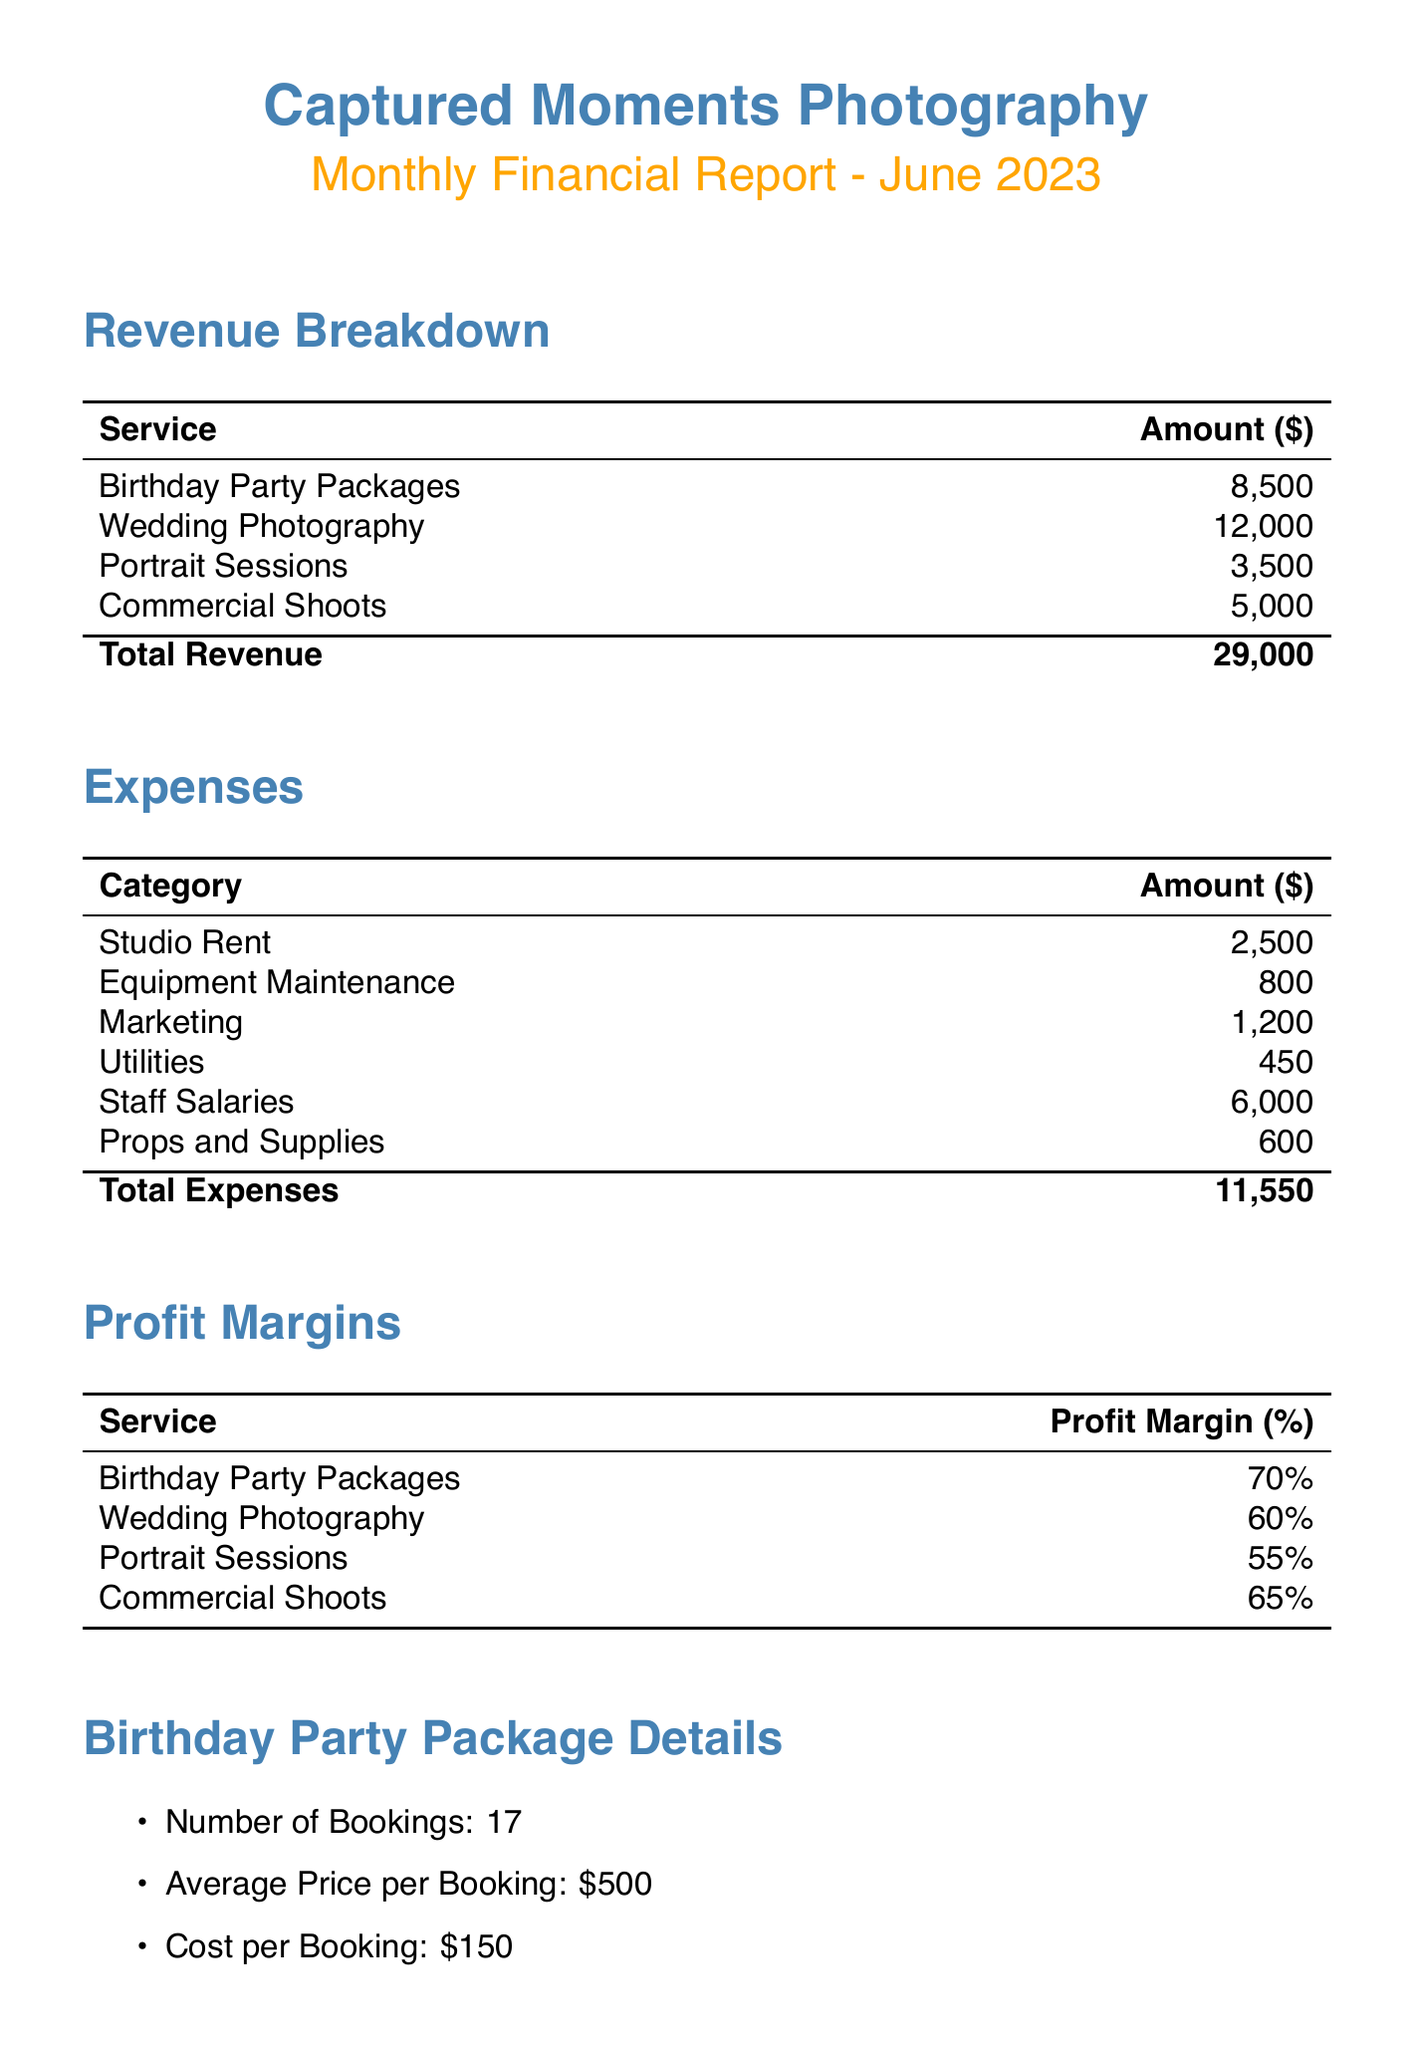what is the total revenue? The total revenue is the sum of all revenue sources in the document: 8500 + 12000 + 3500 + 5000 = 29000.
Answer: 29000 what is the profit margin for birthday party packages? The profit margin for birthday party packages is explicitly stated in the profit margins section of the document.
Answer: 70% how many birthday party bookings were made? The total number of birthday party bookings is detailed in the birthday party package details section of the document.
Answer: 17 which service category has the highest profit margin? The document indicates the profit margins for all services, and the highest profit margin is for birthday party packages.
Answer: Birthday Party Packages what are the total expenses? The total expenses are calculated by adding all listed expenses in the expenses section, which equals 2500 + 800 + 1200 + 450 + 6000 + 600 = 11550.
Answer: 11550 what recommendation was made regarding props? The recommendations section includes a specific suggestion related to props for birthday parties.
Answer: Invest in additional props and themed backdrops for birthday parties how does the number of birthday party bookings compare to the previous month? There is a direct observation made about the comparison of birthday party bookings to the previous month in the key observations section.
Answer: Increased what is the average price per birthday party booking? The average price per booking for birthday party packages is specified in the detailed information about the packages.
Answer: 500 which service has the lowest revenue? The revenue breakdown shows various services, and comparing them reveals the lowest revenue service.
Answer: Portrait Sessions 